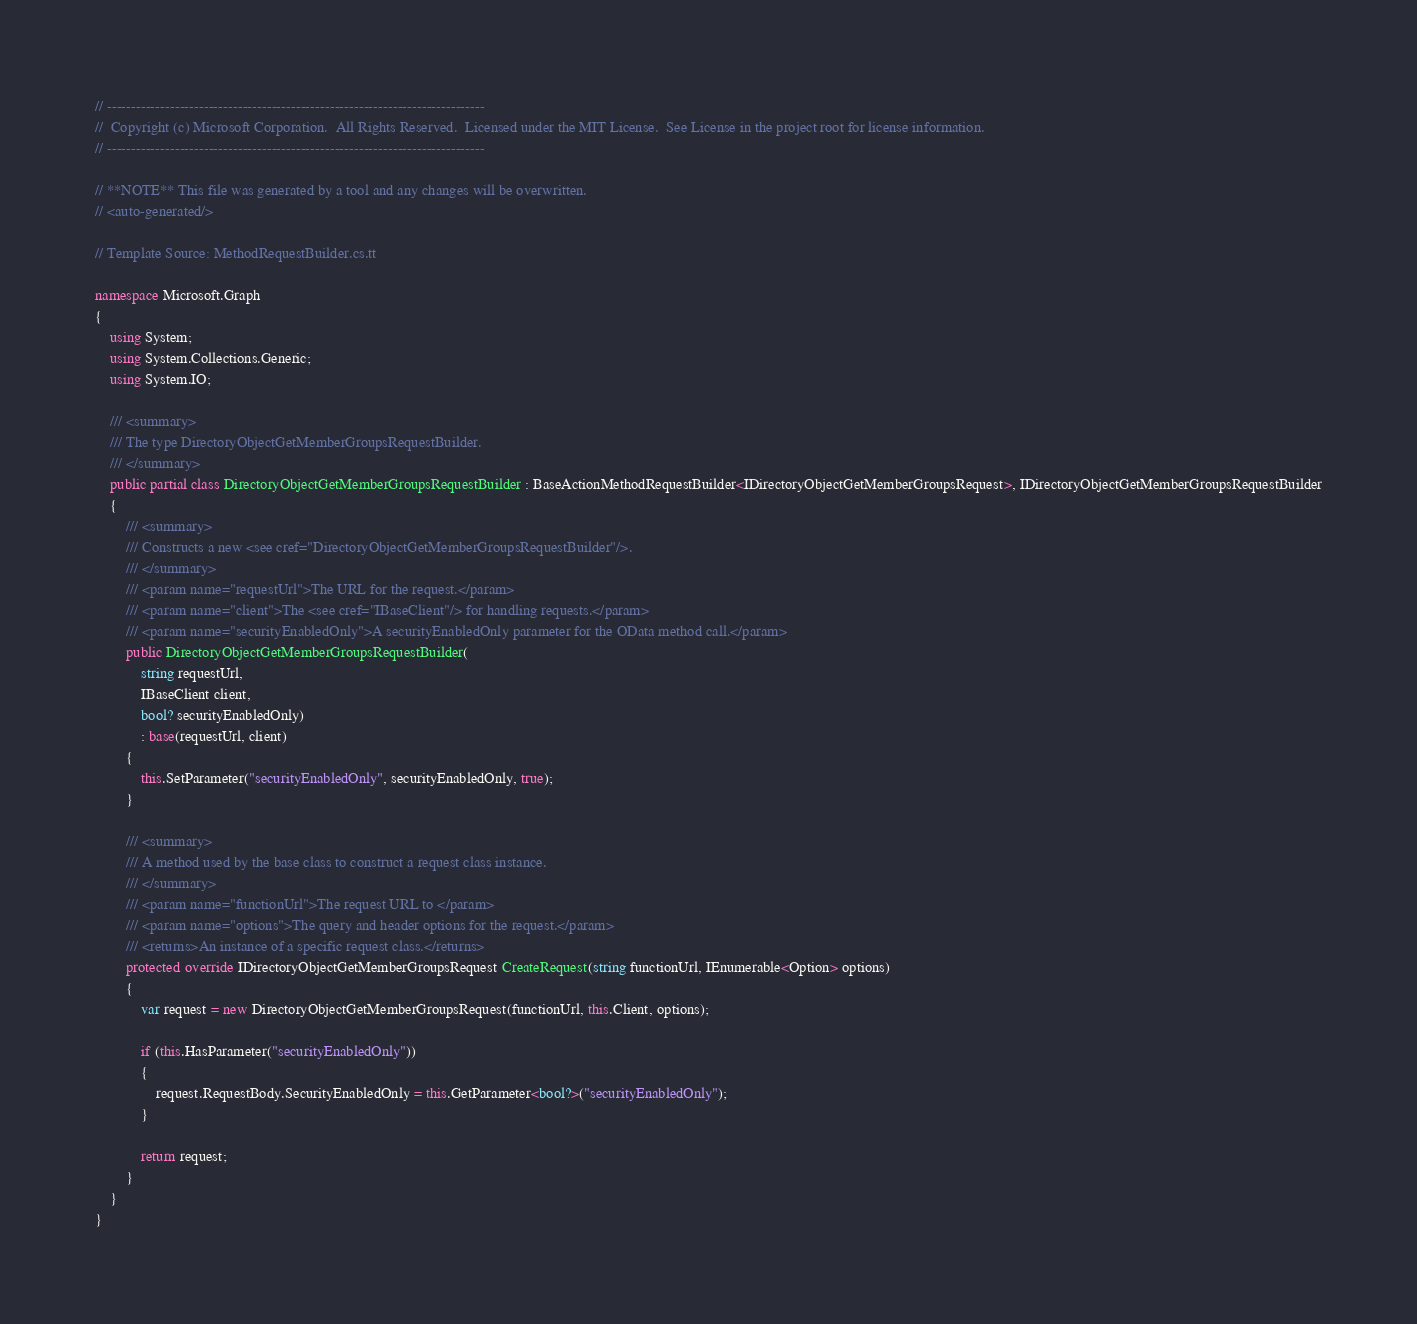<code> <loc_0><loc_0><loc_500><loc_500><_C#_>// ------------------------------------------------------------------------------
//  Copyright (c) Microsoft Corporation.  All Rights Reserved.  Licensed under the MIT License.  See License in the project root for license information.
// ------------------------------------------------------------------------------

// **NOTE** This file was generated by a tool and any changes will be overwritten.
// <auto-generated/>

// Template Source: MethodRequestBuilder.cs.tt

namespace Microsoft.Graph
{
    using System;
    using System.Collections.Generic;
    using System.IO;

    /// <summary>
    /// The type DirectoryObjectGetMemberGroupsRequestBuilder.
    /// </summary>
    public partial class DirectoryObjectGetMemberGroupsRequestBuilder : BaseActionMethodRequestBuilder<IDirectoryObjectGetMemberGroupsRequest>, IDirectoryObjectGetMemberGroupsRequestBuilder
    {
        /// <summary>
        /// Constructs a new <see cref="DirectoryObjectGetMemberGroupsRequestBuilder"/>.
        /// </summary>
        /// <param name="requestUrl">The URL for the request.</param>
        /// <param name="client">The <see cref="IBaseClient"/> for handling requests.</param>
        /// <param name="securityEnabledOnly">A securityEnabledOnly parameter for the OData method call.</param>
        public DirectoryObjectGetMemberGroupsRequestBuilder(
            string requestUrl,
            IBaseClient client,
            bool? securityEnabledOnly)
            : base(requestUrl, client)
        {
            this.SetParameter("securityEnabledOnly", securityEnabledOnly, true);
        }

        /// <summary>
        /// A method used by the base class to construct a request class instance.
        /// </summary>
        /// <param name="functionUrl">The request URL to </param>
        /// <param name="options">The query and header options for the request.</param>
        /// <returns>An instance of a specific request class.</returns>
        protected override IDirectoryObjectGetMemberGroupsRequest CreateRequest(string functionUrl, IEnumerable<Option> options)
        {
            var request = new DirectoryObjectGetMemberGroupsRequest(functionUrl, this.Client, options);

            if (this.HasParameter("securityEnabledOnly"))
            {
                request.RequestBody.SecurityEnabledOnly = this.GetParameter<bool?>("securityEnabledOnly");
            }

            return request;
        }
    }
}
</code> 